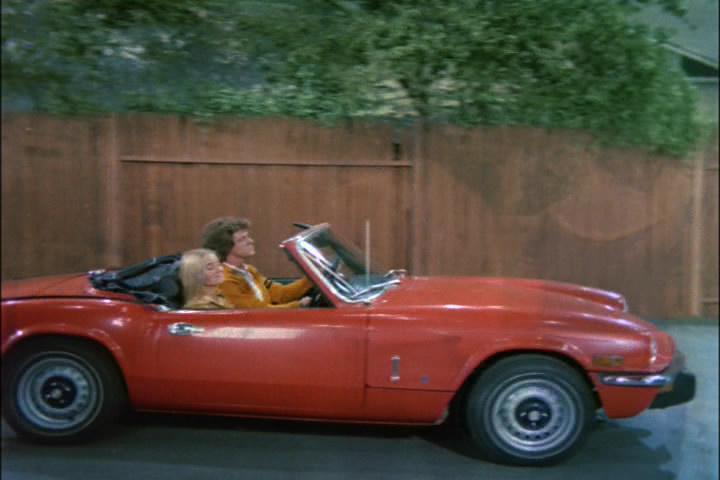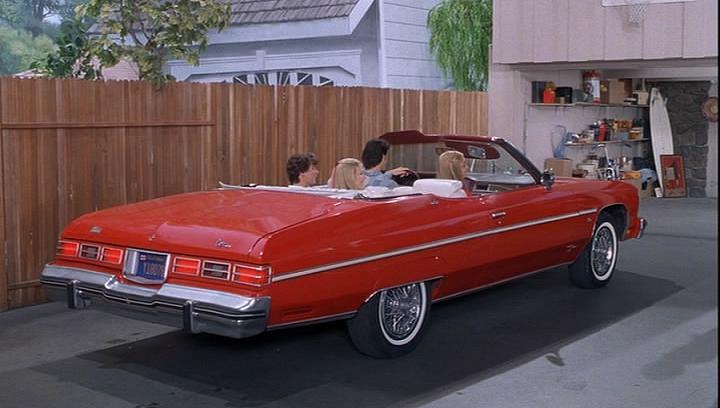The first image is the image on the left, the second image is the image on the right. Analyze the images presented: Is the assertion "In one image, a red convertible is near a body of water, while in a second image, a red car is parked in front of an area of greenery and a white structure." valid? Answer yes or no. No. The first image is the image on the left, the second image is the image on the right. Examine the images to the left and right. Is the description "Right image shows a red forward-angled convertible alongside a rocky shoreline." accurate? Answer yes or no. No. 